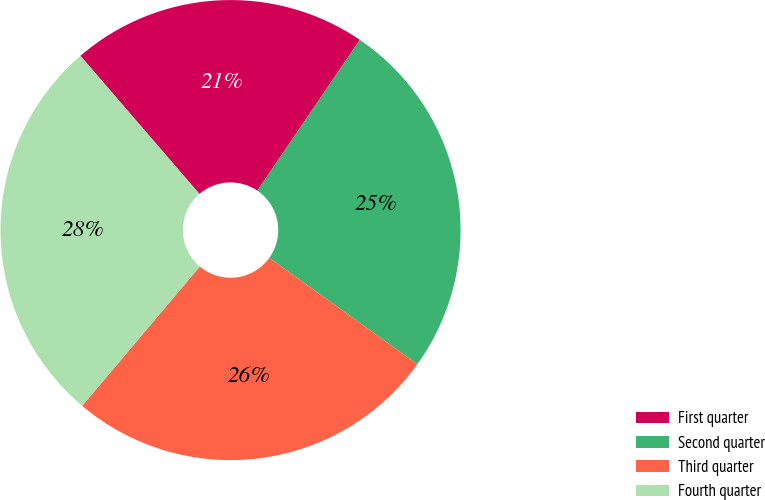Convert chart. <chart><loc_0><loc_0><loc_500><loc_500><pie_chart><fcel>First quarter<fcel>Second quarter<fcel>Third quarter<fcel>Fourth quarter<nl><fcel>20.82%<fcel>25.41%<fcel>26.25%<fcel>27.52%<nl></chart> 